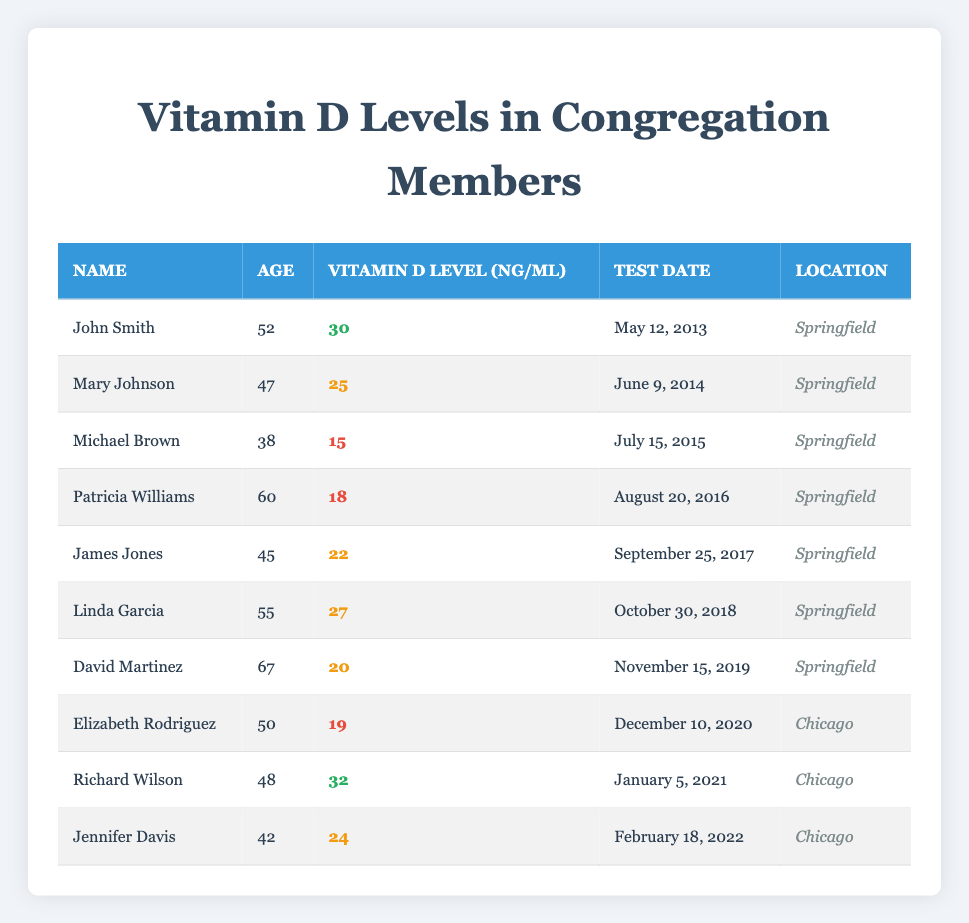What is the vitamin D level of Mary Johnson? Referring to the table, I locate Mary Johnson's row and find that her vitamin D level is listed as 25 ng/mL.
Answer: 25 ng/mL Who is the oldest member listed in the table? By examining the ages in the table, I see that David Martinez is 67 years old, which is the highest age compared to others, confirming he is the oldest member.
Answer: David Martinez How many members have a vitamin D level below 20 ng/mL? I review the vitamin D levels and find that both Michael Brown (15 ng/mL) and Patricia Williams (18 ng/mL) have levels below 20 ng/mL. This totals 2 members.
Answer: 2 What is the average vitamin D level for congregation members from Springfield? I extract the vitamin D levels of Springfield members: 30, 25, 15, 18, 22, 27, and 20. Adding these gives 30 + 25 + 15 + 18 + 22 + 27 + 20 = 167. There are 7 members, so the average level is 167/7 = 23.857, rounded to 24.
Answer: 24 Did anyone in the congregation have a vitamin D level of 32 ng/mL? I scan the table and find that Richard Wilson's vitamin D level is listed as 32 ng/mL, confirming that there is indeed a member with that level.
Answer: Yes What is the difference in vitamin D levels between the highest and lowest recorded levels in the table? The highest level is Richard Wilson at 32 ng/mL and the lowest is Michael Brown at 15 ng/mL. Calculating the difference, we find 32 - 15 = 17 ng/mL.
Answer: 17 ng/mL How many members are located in Chicago? By reviewing the location column, I count the members from Chicago: Elizabeth Rodriguez, Richard Wilson, and Jennifer Davis. This totals 3 members.
Answer: 3 Is it true that Linda Garcia is older than 50? I check Linda Garcia's age from the table, which is 55 years, confirming that she is indeed older than 50.
Answer: Yes What is the total vitamin D level of all members tested in 2021? In the year 2021, only Richard Wilson (32 ng/mL) and Elizabeth Rodriguez (19 ng/mL) are tested, summing those gives 32 + 19 = 51 ng/mL for a total in 2021.
Answer: 51 ng/mL 